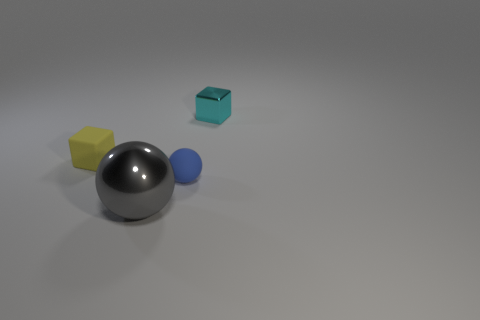Add 4 gray shiny balls. How many objects exist? 8 Subtract all yellow blocks. How many blocks are left? 1 Subtract all cyan metal cylinders. Subtract all matte balls. How many objects are left? 3 Add 4 large metal balls. How many large metal balls are left? 5 Add 2 gray shiny objects. How many gray shiny objects exist? 3 Subtract 0 purple cubes. How many objects are left? 4 Subtract 1 cubes. How many cubes are left? 1 Subtract all yellow balls. Subtract all blue cylinders. How many balls are left? 2 